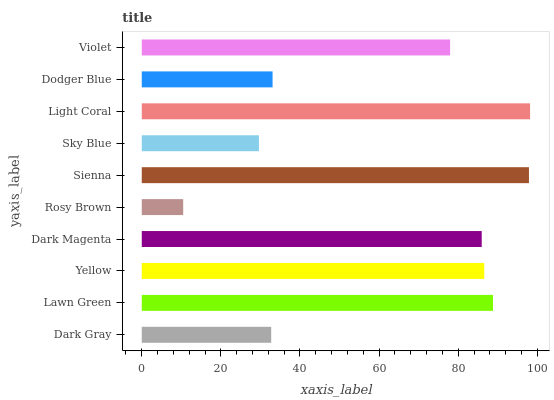Is Rosy Brown the minimum?
Answer yes or no. Yes. Is Light Coral the maximum?
Answer yes or no. Yes. Is Lawn Green the minimum?
Answer yes or no. No. Is Lawn Green the maximum?
Answer yes or no. No. Is Lawn Green greater than Dark Gray?
Answer yes or no. Yes. Is Dark Gray less than Lawn Green?
Answer yes or no. Yes. Is Dark Gray greater than Lawn Green?
Answer yes or no. No. Is Lawn Green less than Dark Gray?
Answer yes or no. No. Is Dark Magenta the high median?
Answer yes or no. Yes. Is Violet the low median?
Answer yes or no. Yes. Is Sky Blue the high median?
Answer yes or no. No. Is Light Coral the low median?
Answer yes or no. No. 